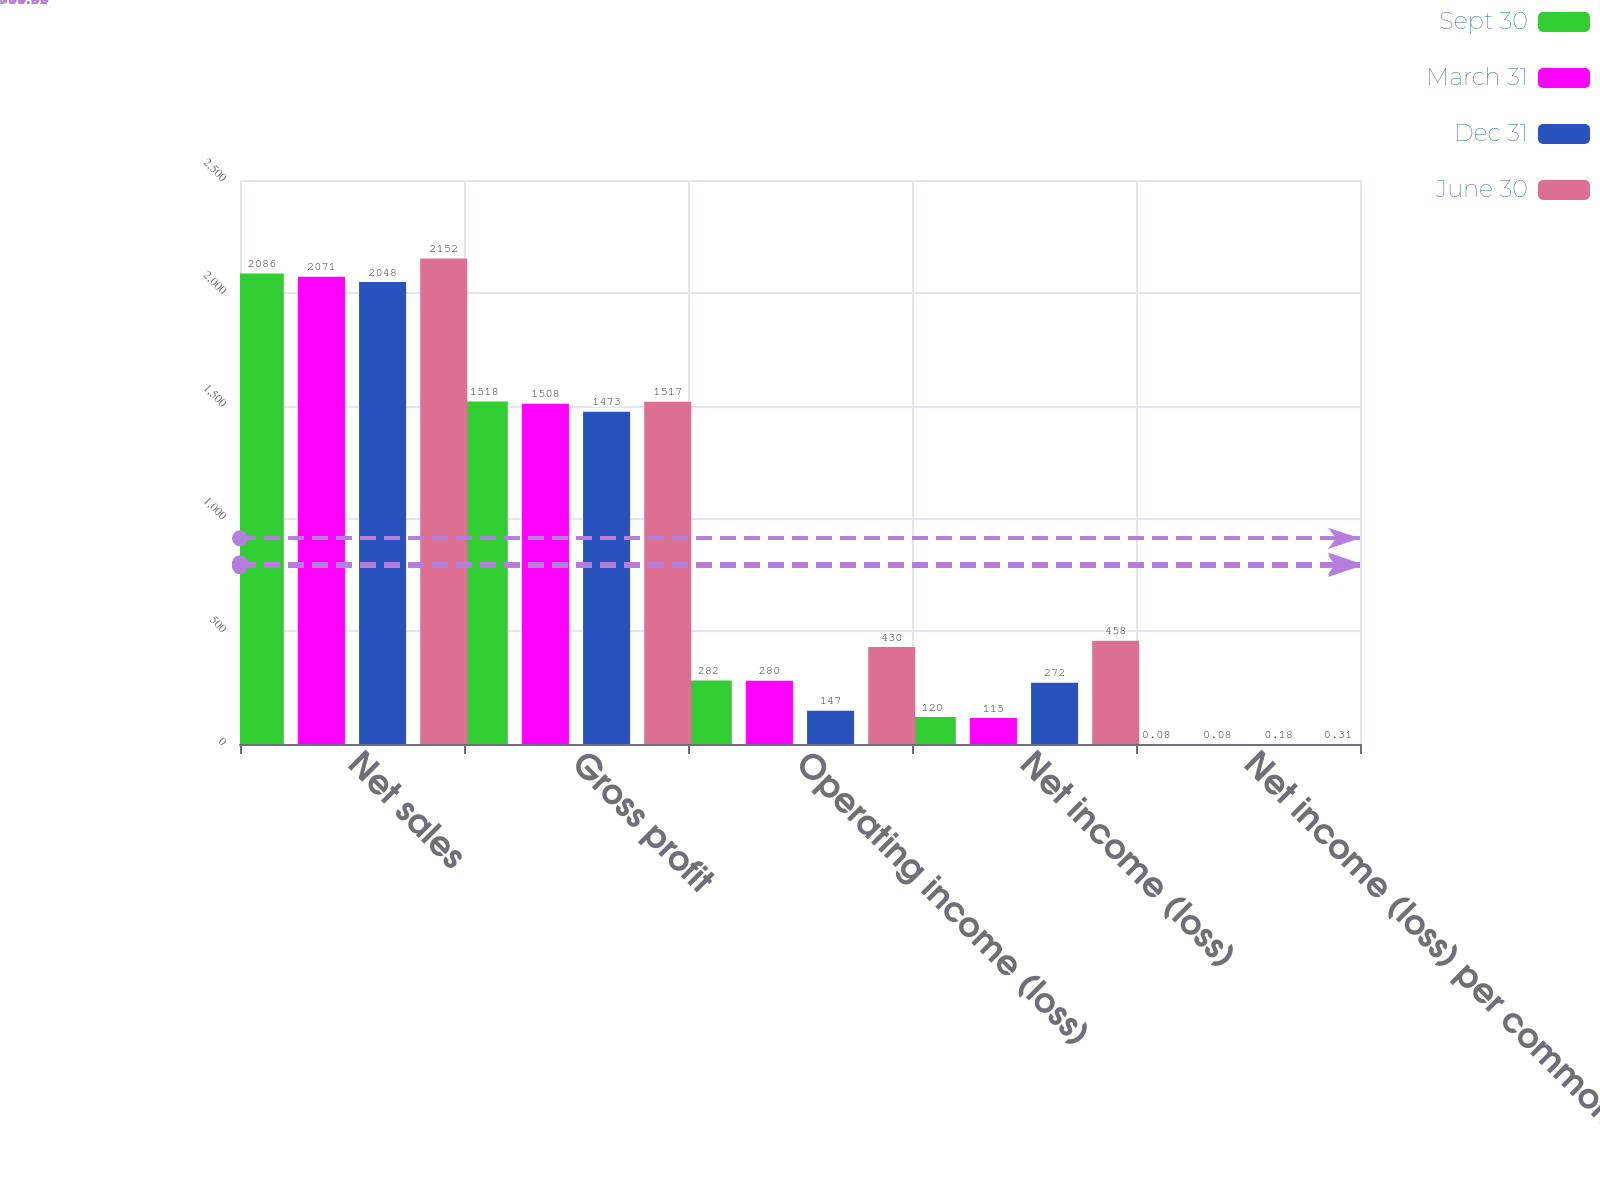<chart> <loc_0><loc_0><loc_500><loc_500><stacked_bar_chart><ecel><fcel>Net sales<fcel>Gross profit<fcel>Operating income (loss)<fcel>Net income (loss)<fcel>Net income (loss) per common<nl><fcel>Sept 30<fcel>2086<fcel>1518<fcel>282<fcel>120<fcel>0.08<nl><fcel>March 31<fcel>2071<fcel>1508<fcel>280<fcel>115<fcel>0.08<nl><fcel>Dec 31<fcel>2048<fcel>1473<fcel>147<fcel>272<fcel>0.18<nl><fcel>June 30<fcel>2152<fcel>1517<fcel>430<fcel>458<fcel>0.31<nl></chart> 